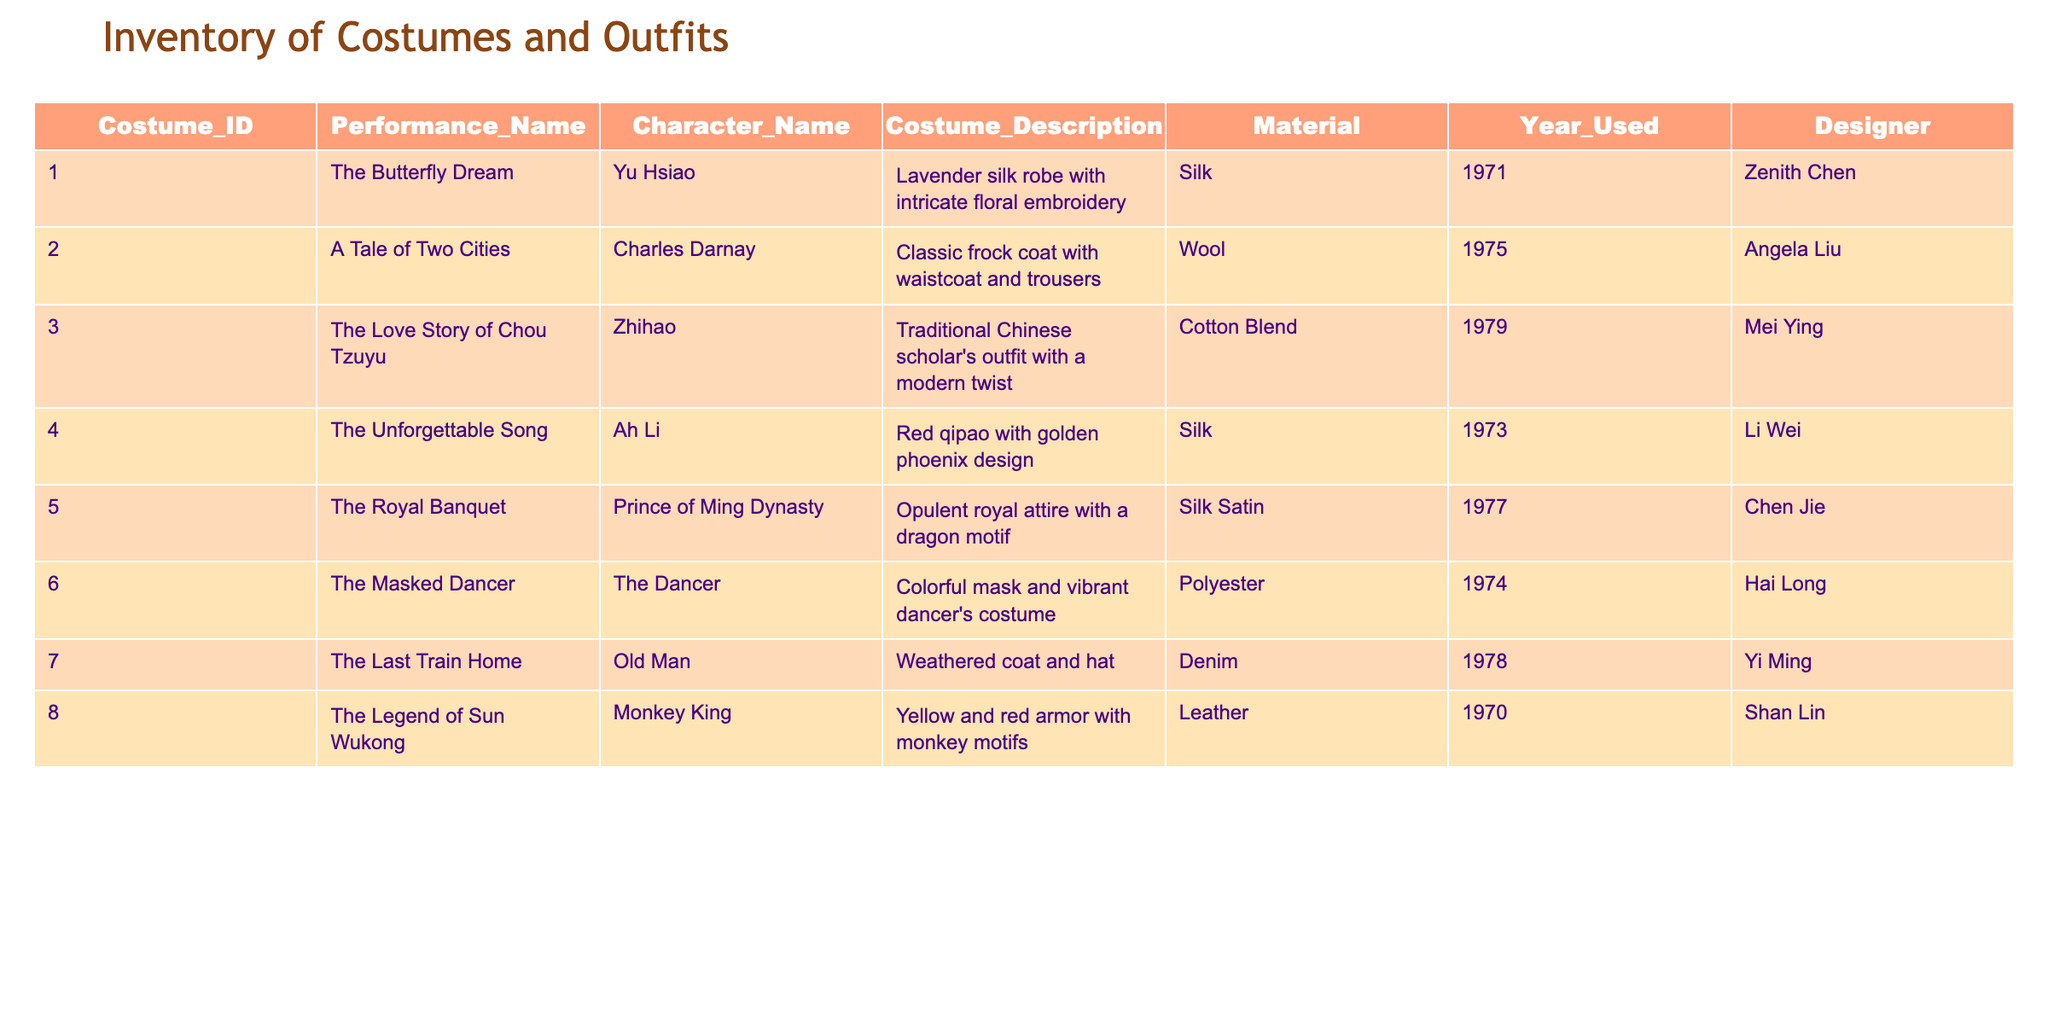What costume was worn by Ah Li? By scanning the table for the row with the character name "Ah Li", we find that the costume worn was a "Red qipao with golden phoenix design."
Answer: Red qipao with golden phoenix design Who designed the costume for Zhihao? Looking at the row corresponding to "Zhihao", the designer listed is "Mei Ying."
Answer: Mei Ying Is there any costume made from polyester? By reviewing the material column, the costume for "The Masked Dancer" is made from polyester.
Answer: Yes How many costumes were used in performances in the 1970s? We count the years used that fall within the range of 1970 to 1979: there are six entries (Costume IDs 1, 2, 4, 5, 6, and 7).
Answer: Six What is the total number of costumes designed by Chen Jie? Filtering the table for entries where the designer is "Chen Jie", we find only one costume ("The Royal Banquet").
Answer: One Did Yu Hsiao wear a silk costume in the performance? Checking the entry for Yu Hsiao, the costume description confirms it is a "Lavender silk robe with intricate floral embroidery," which is indeed silk.
Answer: Yes Which costume has the longest description, and what is that description? Comparing the lengths of the costume descriptions in the table, the longest description belongs to the costume worn by the "Prince of Ming Dynasty," which is "Opulent royal attire with a dragon motif."
Answer: Opulent royal attire with a dragon motif How many costumes from the inventory have a character name starting with 'Z'? By examining character names in the table, only two match: "Zhihao" from "The Love Story of Chou Tzuyu" and "Charles Darnay" from "A Tale of Two Cities." This gives a total of two.
Answer: Two What material was used for the costume worn by the Monkey King? Referring to the table, the costume worn by the "Monkey King" is made of leather.
Answer: Leather 